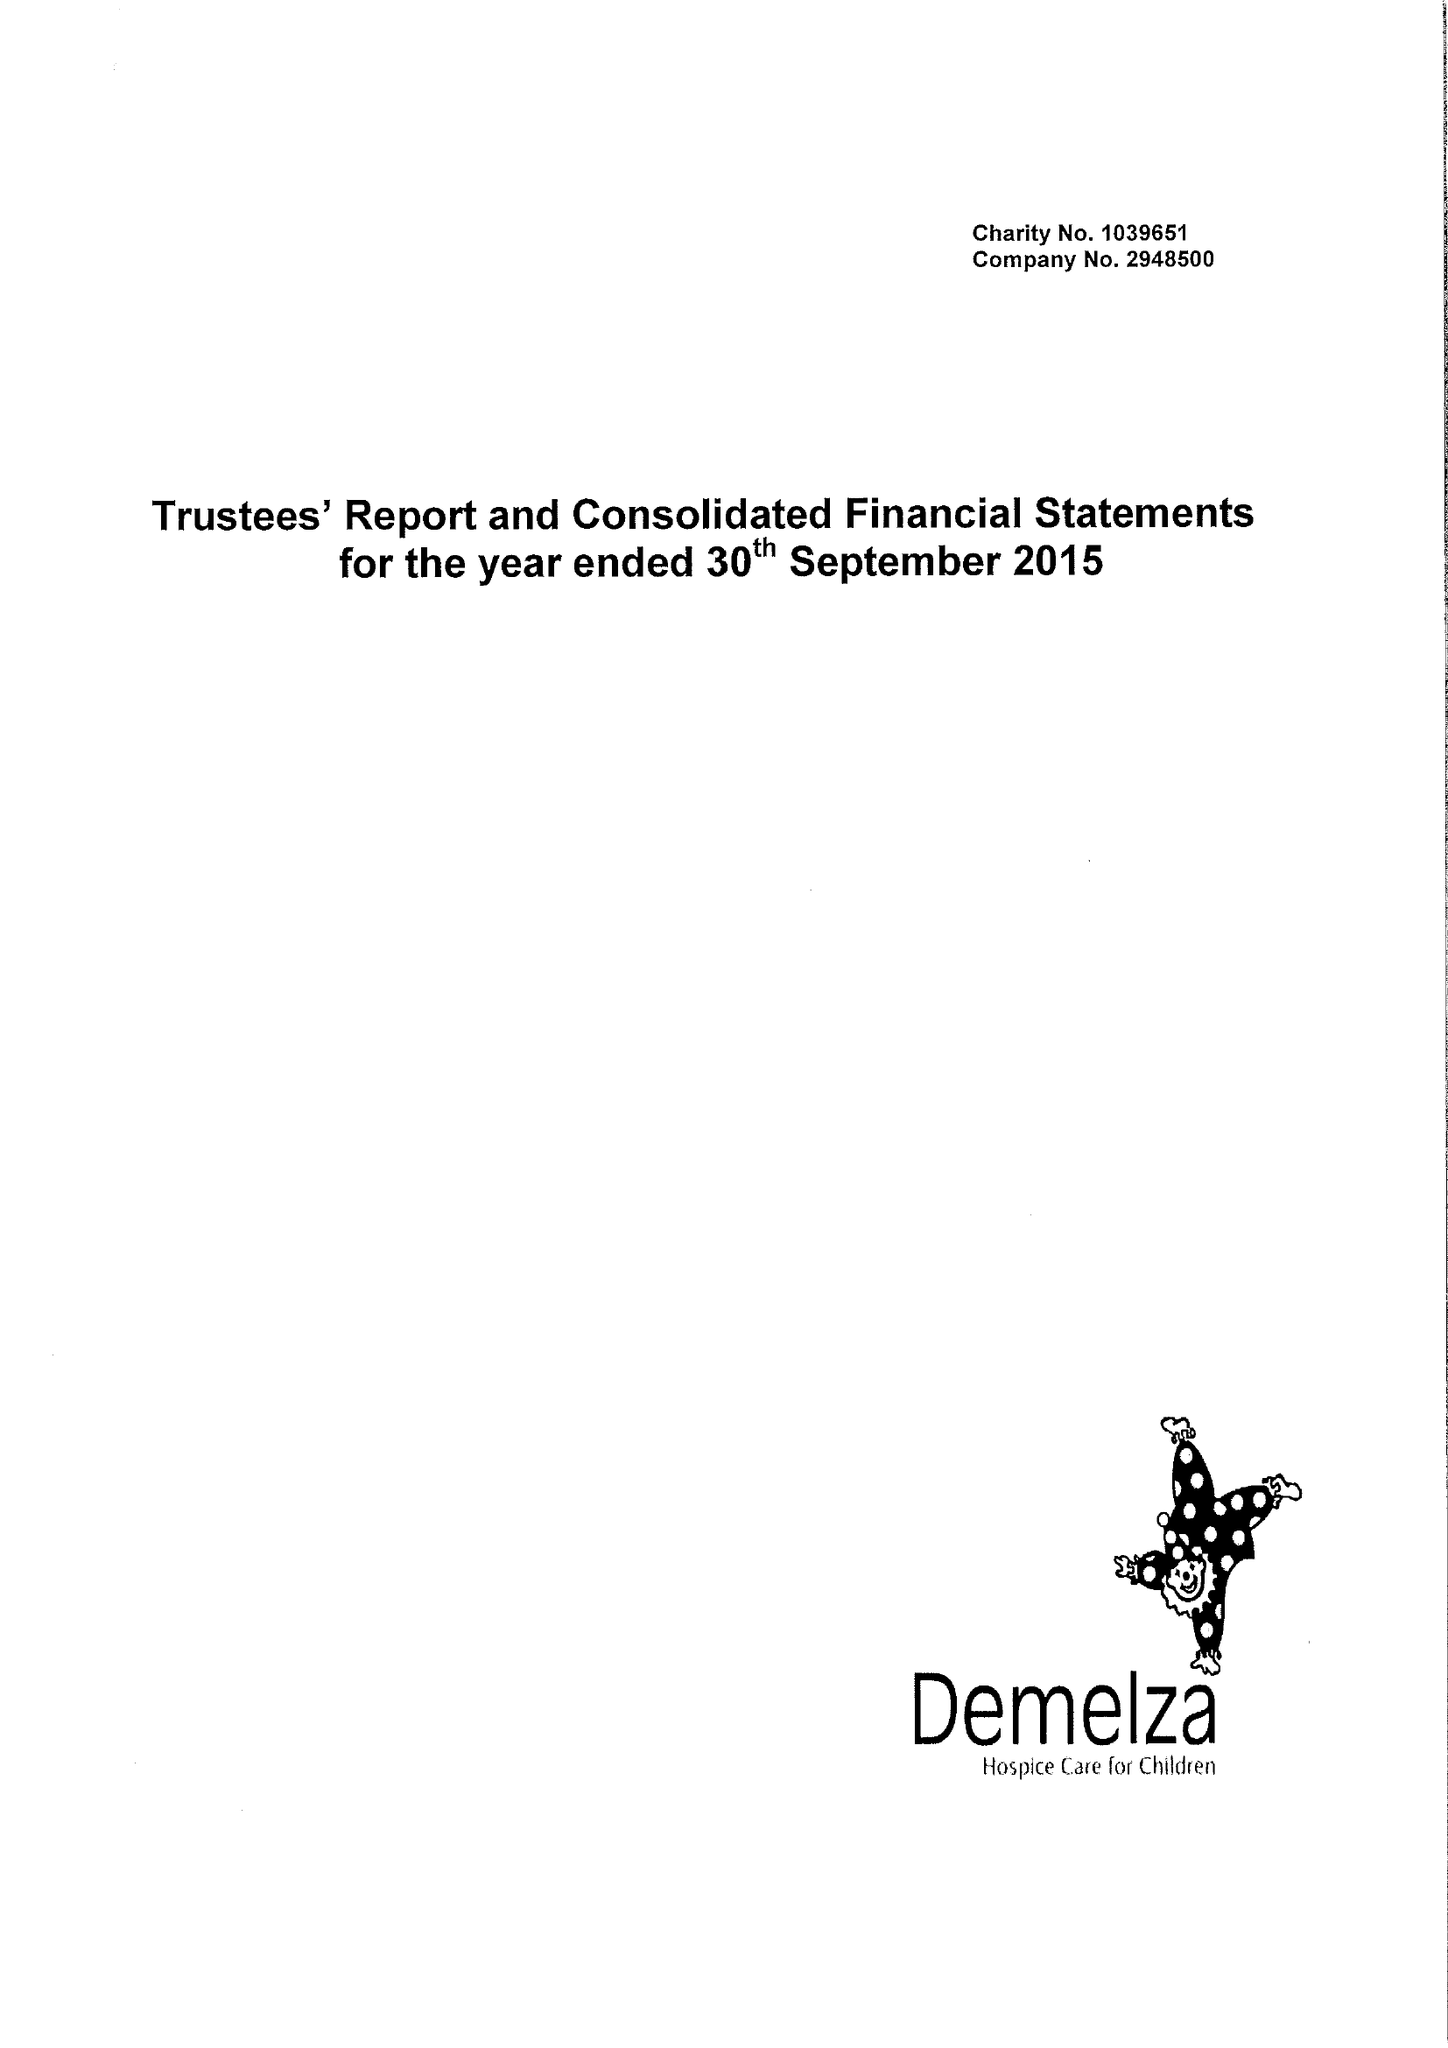What is the value for the income_annually_in_british_pounds?
Answer the question using a single word or phrase. 9762788.00 